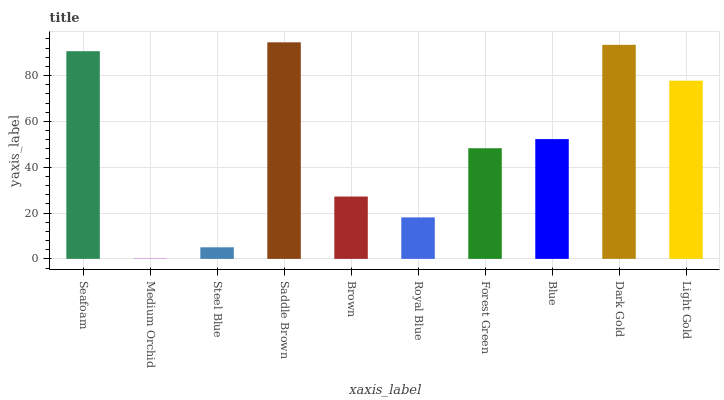Is Medium Orchid the minimum?
Answer yes or no. Yes. Is Saddle Brown the maximum?
Answer yes or no. Yes. Is Steel Blue the minimum?
Answer yes or no. No. Is Steel Blue the maximum?
Answer yes or no. No. Is Steel Blue greater than Medium Orchid?
Answer yes or no. Yes. Is Medium Orchid less than Steel Blue?
Answer yes or no. Yes. Is Medium Orchid greater than Steel Blue?
Answer yes or no. No. Is Steel Blue less than Medium Orchid?
Answer yes or no. No. Is Blue the high median?
Answer yes or no. Yes. Is Forest Green the low median?
Answer yes or no. Yes. Is Brown the high median?
Answer yes or no. No. Is Brown the low median?
Answer yes or no. No. 